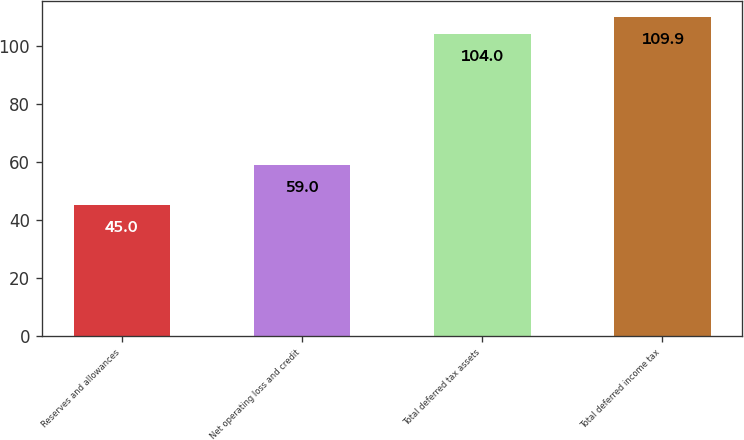Convert chart. <chart><loc_0><loc_0><loc_500><loc_500><bar_chart><fcel>Reserves and allowances<fcel>Net operating loss and credit<fcel>Total deferred tax assets<fcel>Total deferred income tax<nl><fcel>45<fcel>59<fcel>104<fcel>109.9<nl></chart> 